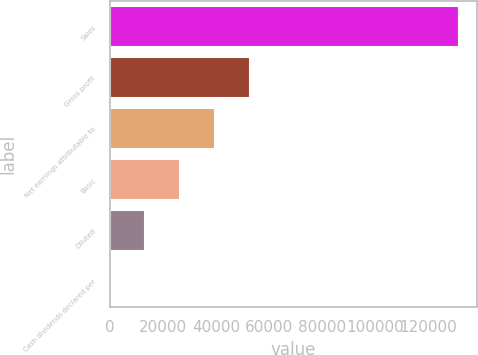<chart> <loc_0><loc_0><loc_500><loc_500><bar_chart><fcel>Sales<fcel>Gross profit<fcel>Net earnings attributable to<fcel>Basic<fcel>Diluted<fcel>Cash dividends declared per<nl><fcel>131537<fcel>52615.8<fcel>39462.3<fcel>26308.7<fcel>13155.2<fcel>1.64<nl></chart> 